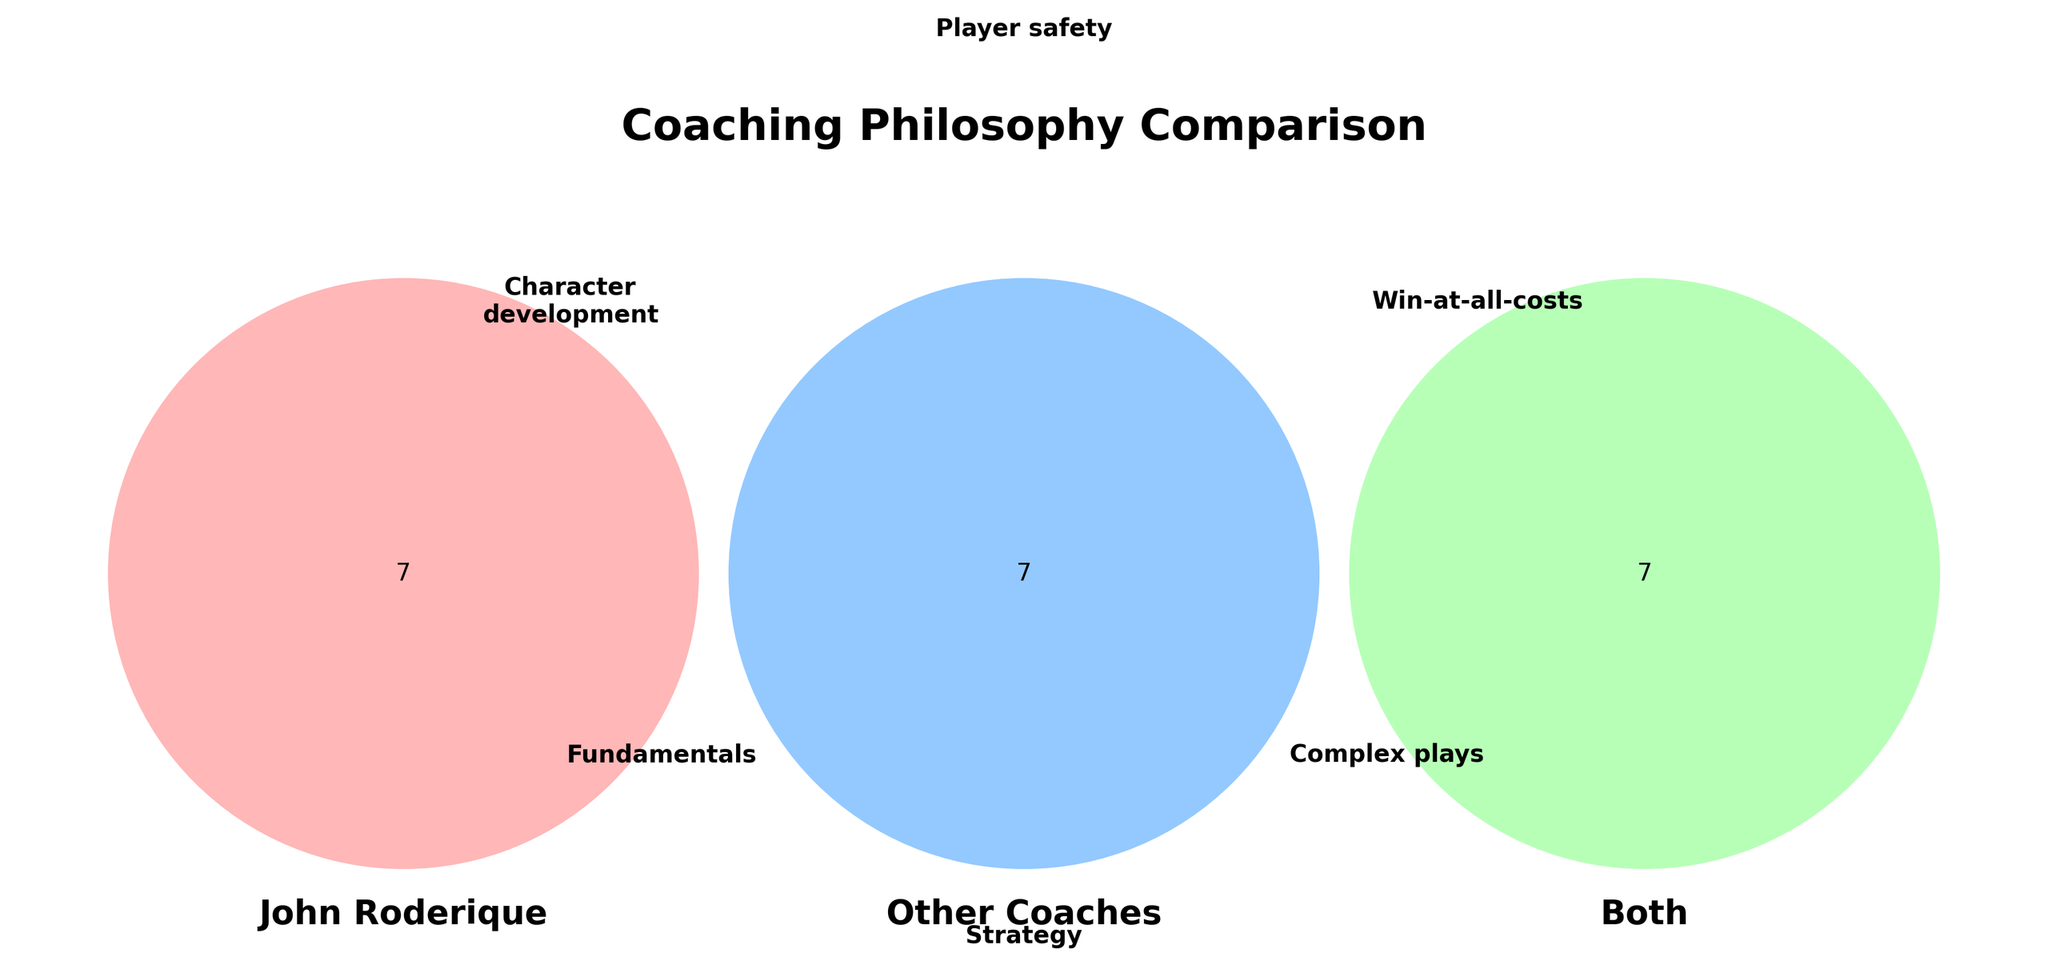What is the common area between John Roderique and other coaches regarding player safety? The common area between John Roderique and other coaches includes keywords shown in the overlapping sections of the Venn Diagram. Player safety is specifically mentioned as being in both categories.
Answer: Player safety How does John Roderique's emphasis on fundamentals compare to other coaches' use of complex playbooks? By looking at the Venn Diagram, John Roderique is associated with fundamentals, and other coaches are associated with complex playbooks. These elements do not overlap, indicating they are distinct focuses.
Answer: They are distinct What is emphasized by all coaches, including John Roderique? The Venn Diagram shows the overlapping area labeled "Both." Common elements in this section are characteristics valued by both John Roderique and other coaches.
Answer: Player safety, game strategy, leadership skills, motivational techniques, recruiting talent, tactical adjustments, physical conditioning Which unique element does John Roderique focus on compared to other coaches? John Roderique's unique elements are found in his section of the Venn Diagram. The elements not overlapping with the other sections are the unique focuses.
Answer: Character development, fundamentals, community involvement, emphasis on education, long-term program building, player-coach relationships, tradition and loyalty Do other coaches prioritize short-term results over long-term program building? According to the Venn Diagram, other coaches have a short-term results focus, while John Roderique emphasizes long-term program building. These elements are shown in their unique areas, not overlapping.
Answer: Yes What is the main difference in leadership style between John Roderique and other coaches? The Venn Diagram shows John Roderique's focus on player-coach relationships, indicating a more personal approach. In contrast, other coaches are associated with a strict authoritarian approach.
Answer: Player-coach relationships vs. strict authoritarian approach Which coaching elements are emphasized in media spotlight for other coaches but not for John Roderique? According to the Venn Diagram, the media spotlight is listed in the "Other Coaches" section but not in John Roderique's section or the common area.
Answer: Media spotlight How does John Roderique's community involvement differ from other coaches' frequent job changes? The Venn Diagram shows John Roderique emphasizing community involvement, while other coaches have frequent job changes. These characteristics do not overlap, indicating they are distinct priorities.
Answer: They are distinct priorities What common elements are shared in leadership skills among John Roderique and other coaches? The common area labeled "Both" in the Venn Diagram includes leadership skills, which are shared by both John Roderique and other coaches.
Answer: Leadership skills Which coaching philosophy includes innovative schemes, John Roderique or other coaches? The Venn Diagram places innovative schemes in the "Other Coaches" section, indicating it is an element emphasized by other coaches and not by John Roderique.
Answer: Other coaches 